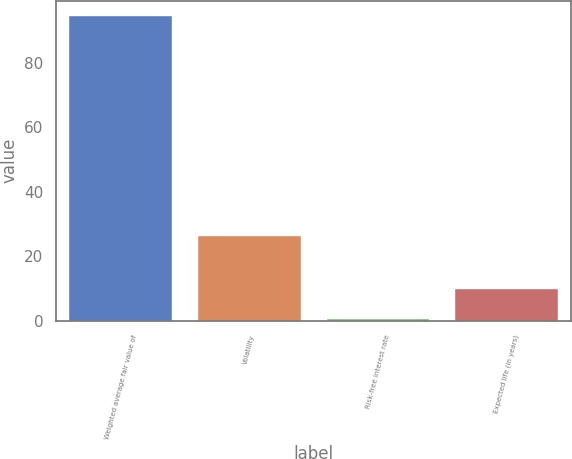Convert chart to OTSL. <chart><loc_0><loc_0><loc_500><loc_500><bar_chart><fcel>Weighted average fair value of<fcel>Volatility<fcel>Risk-free interest rate<fcel>Expected life (in years)<nl><fcel>94.55<fcel>26.41<fcel>0.65<fcel>10.04<nl></chart> 